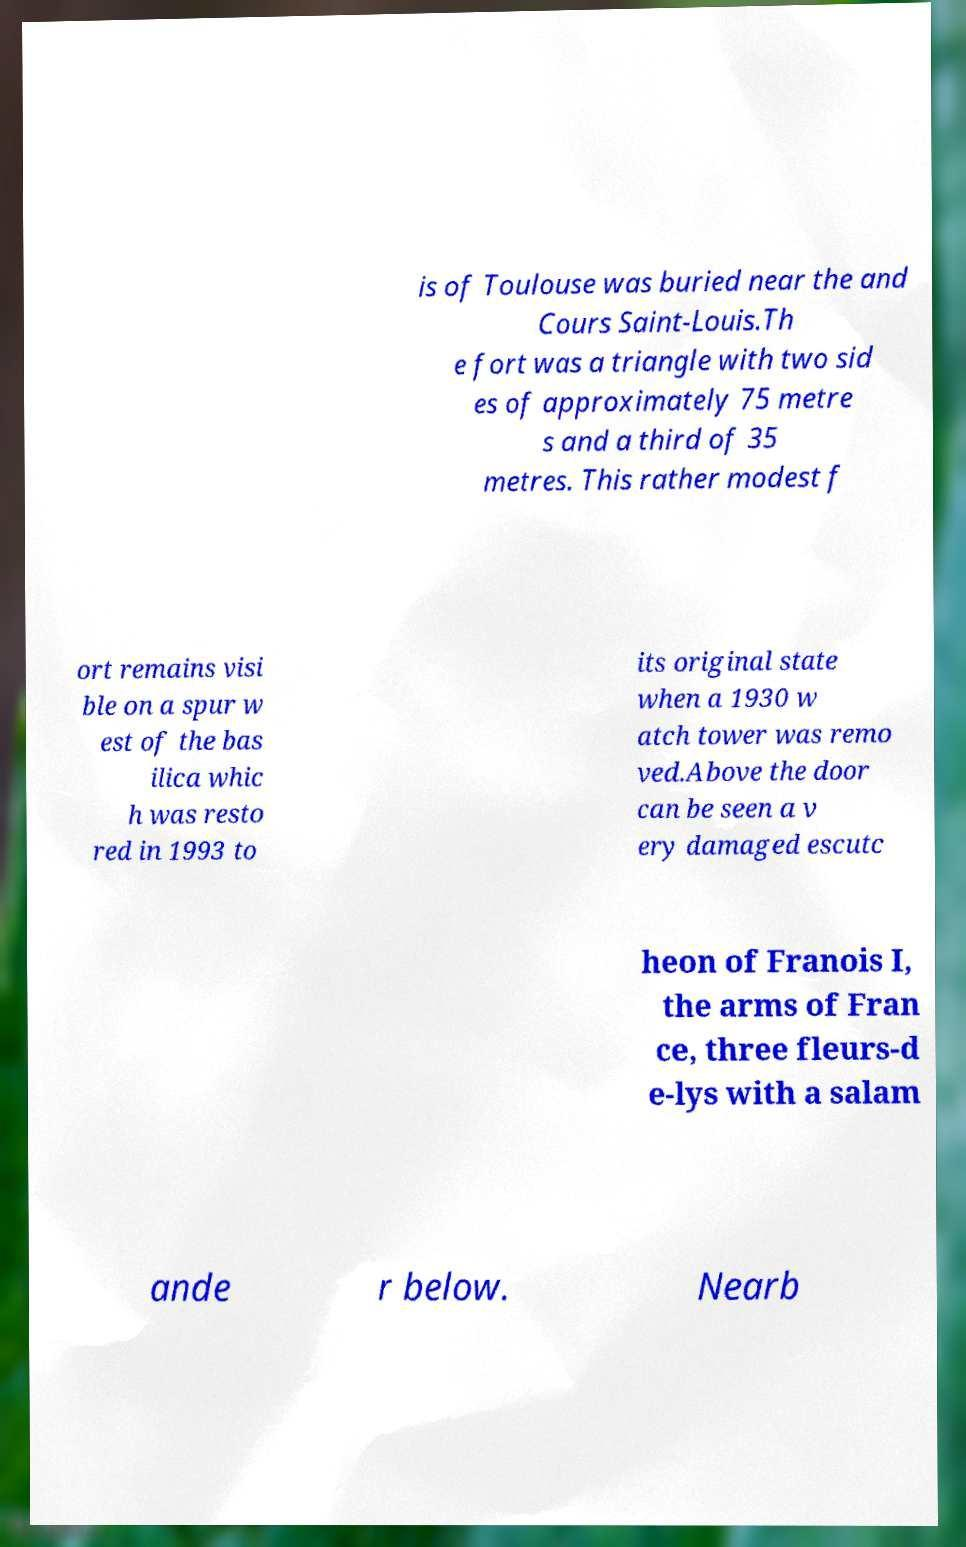I need the written content from this picture converted into text. Can you do that? is of Toulouse was buried near the and Cours Saint-Louis.Th e fort was a triangle with two sid es of approximately 75 metre s and a third of 35 metres. This rather modest f ort remains visi ble on a spur w est of the bas ilica whic h was resto red in 1993 to its original state when a 1930 w atch tower was remo ved.Above the door can be seen a v ery damaged escutc heon of Franois I, the arms of Fran ce, three fleurs-d e-lys with a salam ande r below. Nearb 